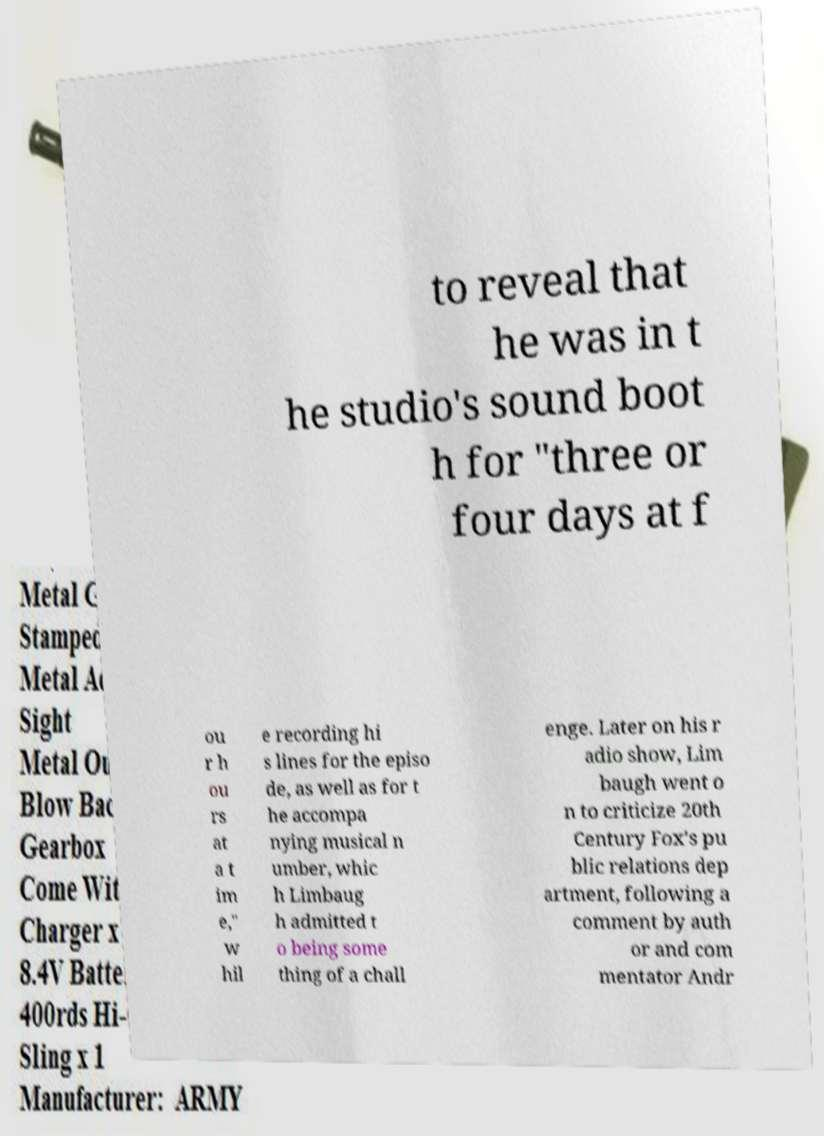Can you accurately transcribe the text from the provided image for me? to reveal that he was in t he studio's sound boot h for "three or four days at f ou r h ou rs at a t im e," w hil e recording hi s lines for the episo de, as well as for t he accompa nying musical n umber, whic h Limbaug h admitted t o being some thing of a chall enge. Later on his r adio show, Lim baugh went o n to criticize 20th Century Fox's pu blic relations dep artment, following a comment by auth or and com mentator Andr 